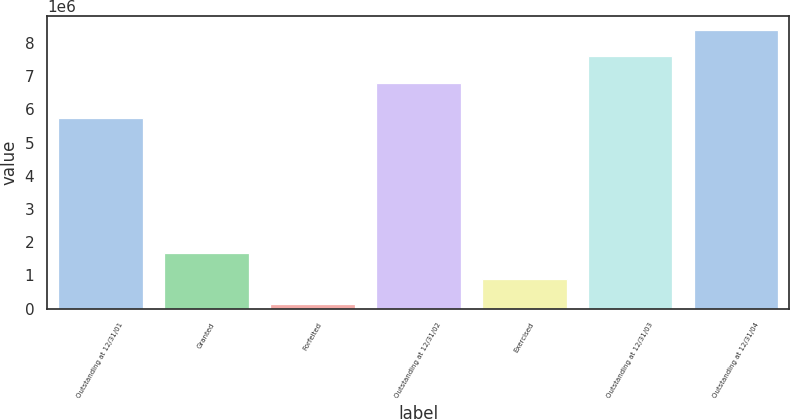Convert chart to OTSL. <chart><loc_0><loc_0><loc_500><loc_500><bar_chart><fcel>Outstanding at 12/31/01<fcel>Granted<fcel>Forfeited<fcel>Outstanding at 12/31/02<fcel>Exercised<fcel>Outstanding at 12/31/03<fcel>Outstanding at 12/31/04<nl><fcel>5.75465e+06<fcel>1.6638e+06<fcel>127450<fcel>6.79765e+06<fcel>895623<fcel>7.61718e+06<fcel>8.38535e+06<nl></chart> 